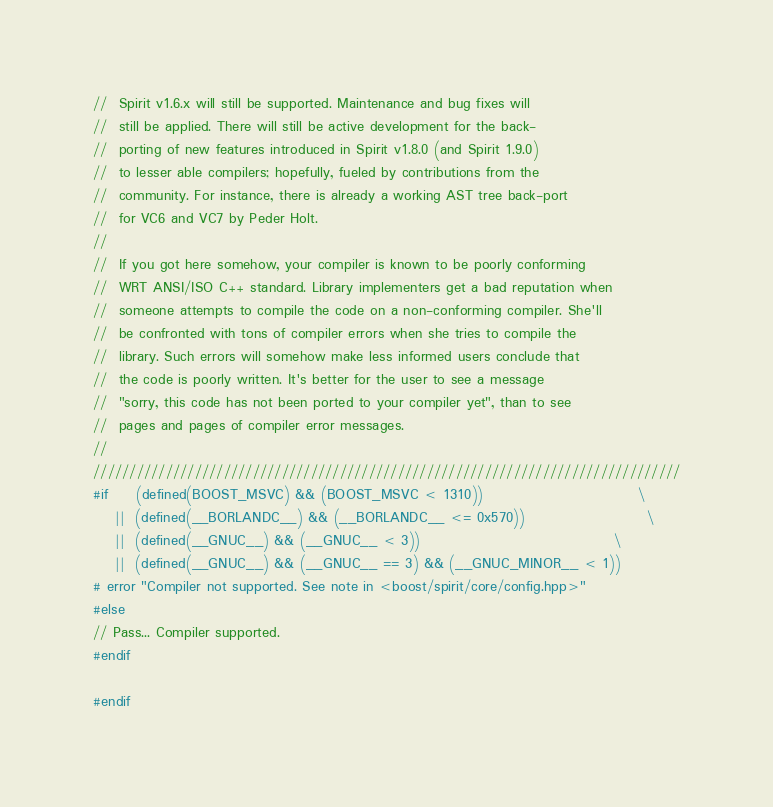Convert code to text. <code><loc_0><loc_0><loc_500><loc_500><_C++_>//  Spirit v1.6.x will still be supported. Maintenance and bug fixes will
//  still be applied. There will still be active development for the back-
//  porting of new features introduced in Spirit v1.8.0 (and Spirit 1.9.0)
//  to lesser able compilers; hopefully, fueled by contributions from the
//  community. For instance, there is already a working AST tree back-port
//  for VC6 and VC7 by Peder Holt.
//
//  If you got here somehow, your compiler is known to be poorly conforming
//  WRT ANSI/ISO C++ standard. Library implementers get a bad reputation when
//  someone attempts to compile the code on a non-conforming compiler. She'll
//  be confronted with tons of compiler errors when she tries to compile the
//  library. Such errors will somehow make less informed users conclude that
//  the code is poorly written. It's better for the user to see a message
//  "sorry, this code has not been ported to your compiler yet", than to see
//  pages and pages of compiler error messages.
//
/////////////////////////////////////////////////////////////////////////////////
#if     (defined(BOOST_MSVC) && (BOOST_MSVC < 1310))                            \
    ||  (defined(__BORLANDC__) && (__BORLANDC__ <= 0x570))                      \
    ||  (defined(__GNUC__) && (__GNUC__ < 3))                                   \
    ||  (defined(__GNUC__) && (__GNUC__ == 3) && (__GNUC_MINOR__ < 1))
# error "Compiler not supported. See note in <boost/spirit/core/config.hpp>"
#else
// Pass... Compiler supported.
#endif

#endif


</code> 